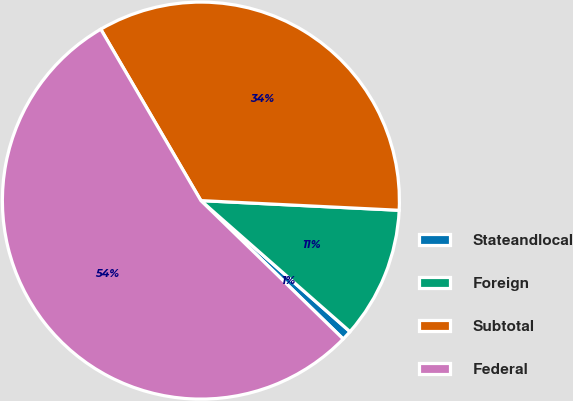Convert chart. <chart><loc_0><loc_0><loc_500><loc_500><pie_chart><fcel>Stateandlocal<fcel>Foreign<fcel>Subtotal<fcel>Federal<nl><fcel>0.8%<fcel>10.7%<fcel>34.19%<fcel>54.31%<nl></chart> 